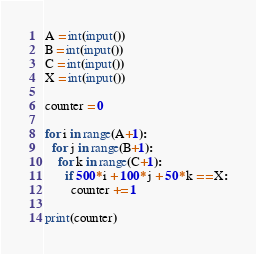<code> <loc_0><loc_0><loc_500><loc_500><_Python_>A = int(input())
B = int(input())
C = int(input())
X = int(input())

counter = 0

for i in range(A+1):
  for j in range(B+1):
    for k in range(C+1):
      if 500*i + 100*j + 50*k == X:
        counter += 1

print(counter)</code> 